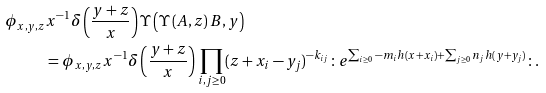Convert formula to latex. <formula><loc_0><loc_0><loc_500><loc_500>\phi _ { x , y , z } & x ^ { - 1 } \delta \left ( \frac { y + z } { x } \right ) \Upsilon \left ( \Upsilon \left ( A , z \right ) B , y \right ) \\ & = \phi _ { x , y , z } x ^ { - 1 } \delta \left ( \frac { y + z } { x } \right ) \prod _ { i , j \geq 0 } ( z + x _ { i } - y _ { j } ) ^ { - k _ { i j } } \colon e ^ { \sum _ { i \geq 0 } - m _ { i } h ( x + x _ { i } ) + \sum _ { j \geq 0 } n _ { j } h ( y + y _ { j } ) } \colon .</formula> 